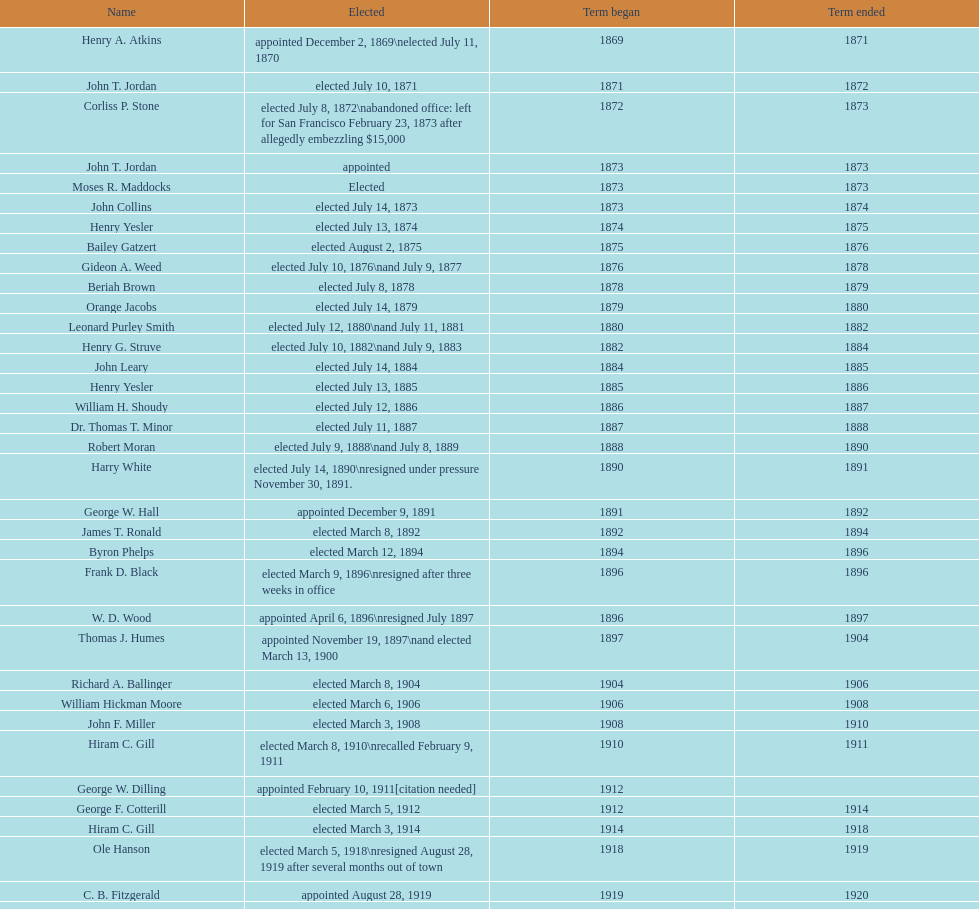Which seattle, washington mayor stepped down after just three weeks in office in 1896? Frank D. Black. 